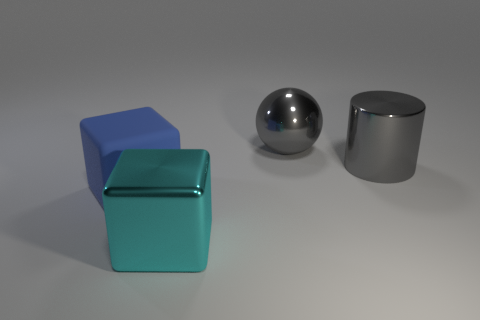Add 1 big shiny cylinders. How many objects exist? 5 Subtract 1 cyan cubes. How many objects are left? 3 Subtract all spheres. How many objects are left? 3 Subtract all large cyan blocks. Subtract all things. How many objects are left? 2 Add 2 big blocks. How many big blocks are left? 4 Add 4 cyan spheres. How many cyan spheres exist? 4 